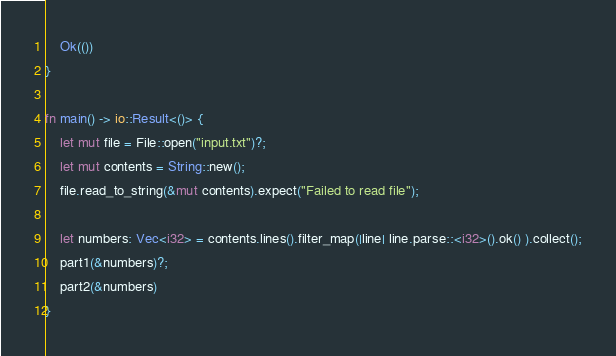<code> <loc_0><loc_0><loc_500><loc_500><_Rust_>    Ok(())
}

fn main() -> io::Result<()> {
    let mut file = File::open("input.txt")?;
    let mut contents = String::new();
    file.read_to_string(&mut contents).expect("Failed to read file");
    
    let numbers: Vec<i32> = contents.lines().filter_map(|line| line.parse::<i32>().ok() ).collect();
    part1(&numbers)?;
    part2(&numbers)
}
</code> 